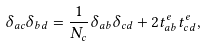<formula> <loc_0><loc_0><loc_500><loc_500>\delta _ { a c } \delta _ { b d } = \frac { 1 } { N _ { c } } \delta _ { a b } \delta _ { c d } + 2 t _ { a b } ^ { e } t _ { c d } ^ { e } ,</formula> 